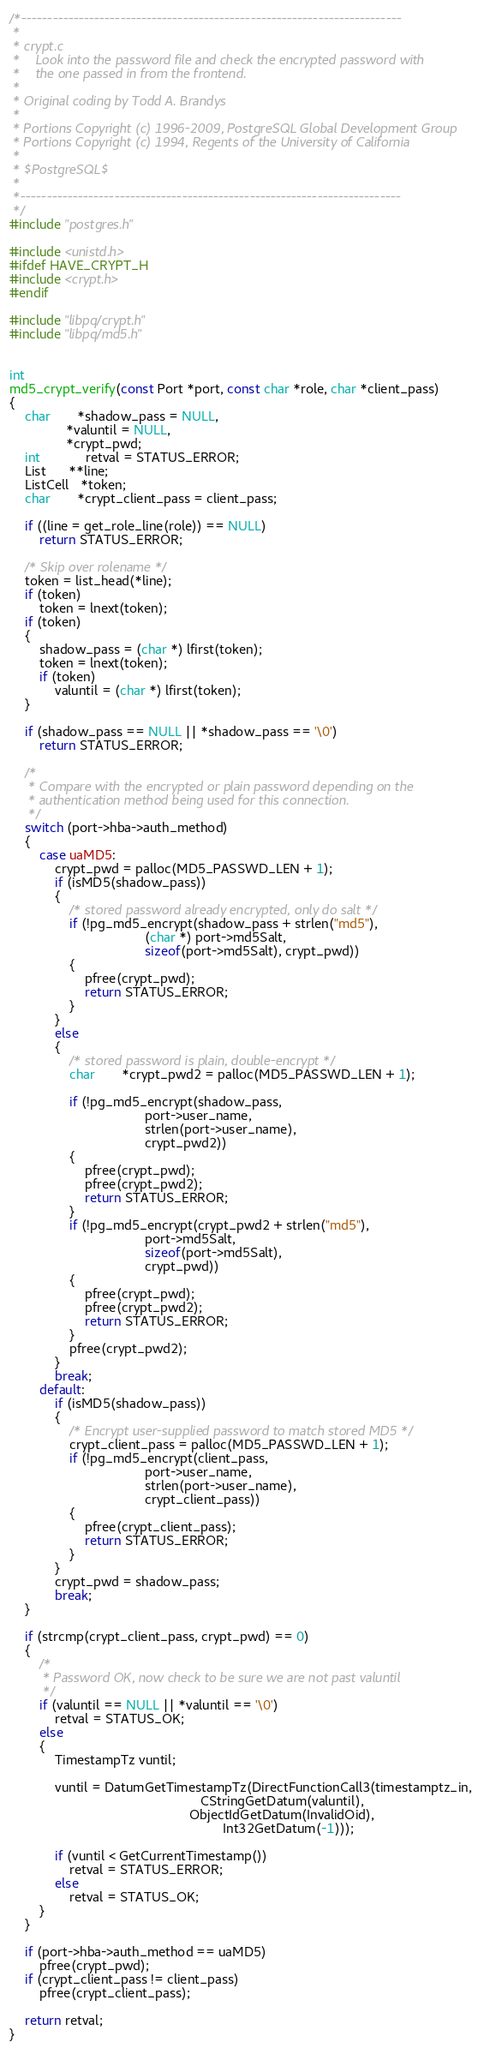Convert code to text. <code><loc_0><loc_0><loc_500><loc_500><_C_>/*-------------------------------------------------------------------------
 *
 * crypt.c
 *	  Look into the password file and check the encrypted password with
 *	  the one passed in from the frontend.
 *
 * Original coding by Todd A. Brandys
 *
 * Portions Copyright (c) 1996-2009, PostgreSQL Global Development Group
 * Portions Copyright (c) 1994, Regents of the University of California
 *
 * $PostgreSQL$
 *
 *-------------------------------------------------------------------------
 */
#include "postgres.h"

#include <unistd.h>
#ifdef HAVE_CRYPT_H
#include <crypt.h>
#endif

#include "libpq/crypt.h"
#include "libpq/md5.h"


int
md5_crypt_verify(const Port *port, const char *role, char *client_pass)
{
	char	   *shadow_pass = NULL,
			   *valuntil = NULL,
			   *crypt_pwd;
	int			retval = STATUS_ERROR;
	List	  **line;
	ListCell   *token;
	char	   *crypt_client_pass = client_pass;

	if ((line = get_role_line(role)) == NULL)
		return STATUS_ERROR;

	/* Skip over rolename */
	token = list_head(*line);
	if (token)
		token = lnext(token);
	if (token)
	{
		shadow_pass = (char *) lfirst(token);
		token = lnext(token);
		if (token)
			valuntil = (char *) lfirst(token);
	}

	if (shadow_pass == NULL || *shadow_pass == '\0')
		return STATUS_ERROR;

	/*
	 * Compare with the encrypted or plain password depending on the
	 * authentication method being used for this connection.
	 */
	switch (port->hba->auth_method)
	{
		case uaMD5:
			crypt_pwd = palloc(MD5_PASSWD_LEN + 1);
			if (isMD5(shadow_pass))
			{
				/* stored password already encrypted, only do salt */
				if (!pg_md5_encrypt(shadow_pass + strlen("md5"),
									(char *) port->md5Salt,
									sizeof(port->md5Salt), crypt_pwd))
				{
					pfree(crypt_pwd);
					return STATUS_ERROR;
				}
			}
			else
			{
				/* stored password is plain, double-encrypt */
				char	   *crypt_pwd2 = palloc(MD5_PASSWD_LEN + 1);

				if (!pg_md5_encrypt(shadow_pass,
									port->user_name,
									strlen(port->user_name),
									crypt_pwd2))
				{
					pfree(crypt_pwd);
					pfree(crypt_pwd2);
					return STATUS_ERROR;
				}
				if (!pg_md5_encrypt(crypt_pwd2 + strlen("md5"),
									port->md5Salt,
									sizeof(port->md5Salt),
									crypt_pwd))
				{
					pfree(crypt_pwd);
					pfree(crypt_pwd2);
					return STATUS_ERROR;
				}
				pfree(crypt_pwd2);
			}
			break;
		default:
			if (isMD5(shadow_pass))
			{
				/* Encrypt user-supplied password to match stored MD5 */
				crypt_client_pass = palloc(MD5_PASSWD_LEN + 1);
				if (!pg_md5_encrypt(client_pass,
									port->user_name,
									strlen(port->user_name),
									crypt_client_pass))
				{
					pfree(crypt_client_pass);
					return STATUS_ERROR;
				}
			}
			crypt_pwd = shadow_pass;
			break;
	}

	if (strcmp(crypt_client_pass, crypt_pwd) == 0)
	{
		/*
		 * Password OK, now check to be sure we are not past valuntil
		 */
		if (valuntil == NULL || *valuntil == '\0')
			retval = STATUS_OK;
		else
		{
			TimestampTz vuntil;

			vuntil = DatumGetTimestampTz(DirectFunctionCall3(timestamptz_in,
												   CStringGetDatum(valuntil),
												ObjectIdGetDatum(InvalidOid),
														 Int32GetDatum(-1)));

			if (vuntil < GetCurrentTimestamp())
				retval = STATUS_ERROR;
			else
				retval = STATUS_OK;
		}
	}

	if (port->hba->auth_method == uaMD5)
		pfree(crypt_pwd);
	if (crypt_client_pass != client_pass)
		pfree(crypt_client_pass);

	return retval;
}
</code> 